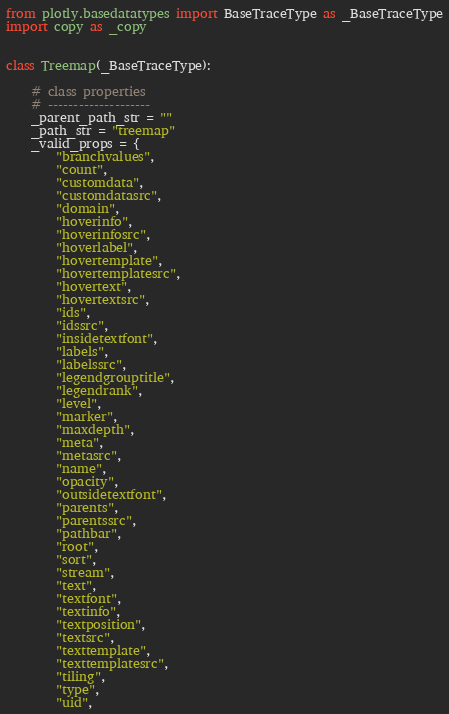<code> <loc_0><loc_0><loc_500><loc_500><_Python_>from plotly.basedatatypes import BaseTraceType as _BaseTraceType
import copy as _copy


class Treemap(_BaseTraceType):

    # class properties
    # --------------------
    _parent_path_str = ""
    _path_str = "treemap"
    _valid_props = {
        "branchvalues",
        "count",
        "customdata",
        "customdatasrc",
        "domain",
        "hoverinfo",
        "hoverinfosrc",
        "hoverlabel",
        "hovertemplate",
        "hovertemplatesrc",
        "hovertext",
        "hovertextsrc",
        "ids",
        "idssrc",
        "insidetextfont",
        "labels",
        "labelssrc",
        "legendgrouptitle",
        "legendrank",
        "level",
        "marker",
        "maxdepth",
        "meta",
        "metasrc",
        "name",
        "opacity",
        "outsidetextfont",
        "parents",
        "parentssrc",
        "pathbar",
        "root",
        "sort",
        "stream",
        "text",
        "textfont",
        "textinfo",
        "textposition",
        "textsrc",
        "texttemplate",
        "texttemplatesrc",
        "tiling",
        "type",
        "uid",</code> 